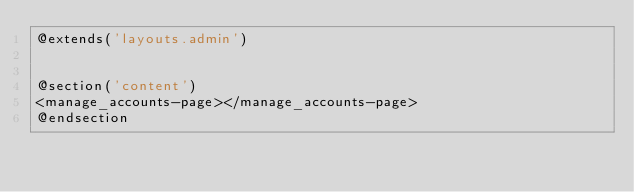Convert code to text. <code><loc_0><loc_0><loc_500><loc_500><_PHP_>@extends('layouts.admin')


@section('content')
<manage_accounts-page></manage_accounts-page>
@endsection</code> 